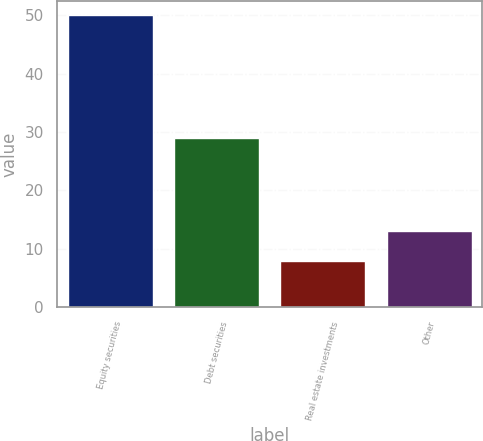Convert chart to OTSL. <chart><loc_0><loc_0><loc_500><loc_500><bar_chart><fcel>Equity securities<fcel>Debt securities<fcel>Real estate investments<fcel>Other<nl><fcel>50<fcel>29<fcel>8<fcel>13<nl></chart> 